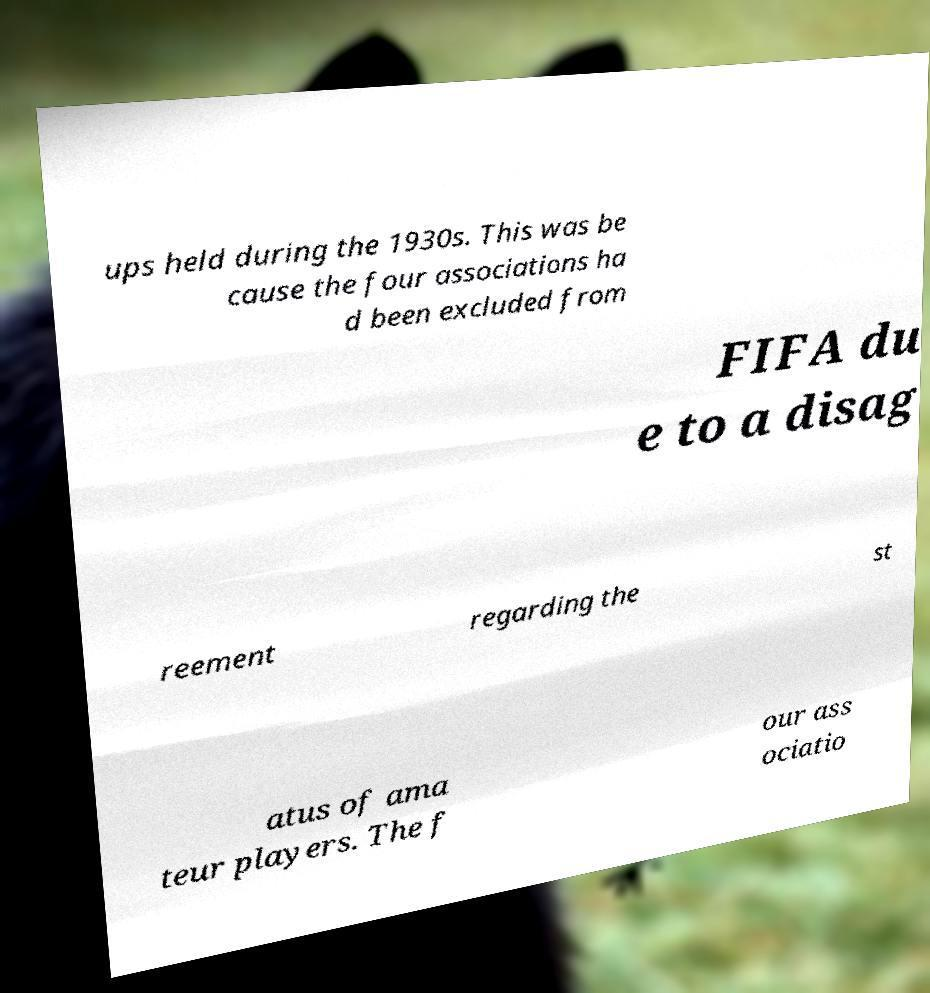Please read and relay the text visible in this image. What does it say? ups held during the 1930s. This was be cause the four associations ha d been excluded from FIFA du e to a disag reement regarding the st atus of ama teur players. The f our ass ociatio 